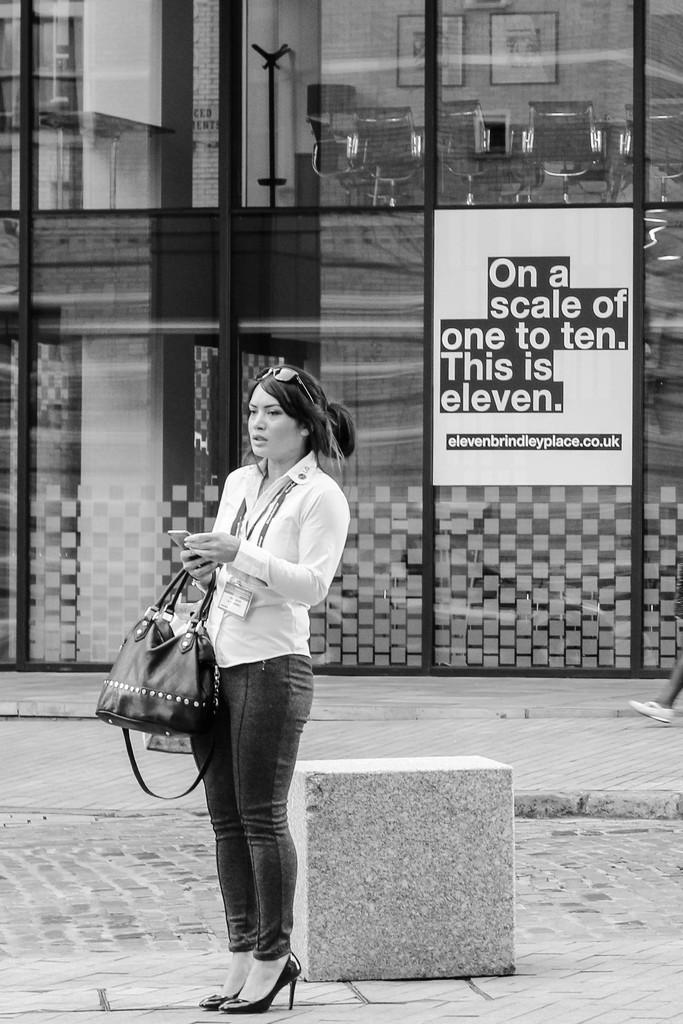What is the main subject of the image? The main subject of the image is a woman. What is the woman holding in her hand? The woman is holding a handbag in her hand. Is there anything attached to the woman's back? Yes, there is a poster on the woman's back. What unit of measurement is the example of knowledge being displayed in the image? There is no unit of measurement or example of knowledge being displayed in the image; it features a woman holding a handbag and a poster on her back. 